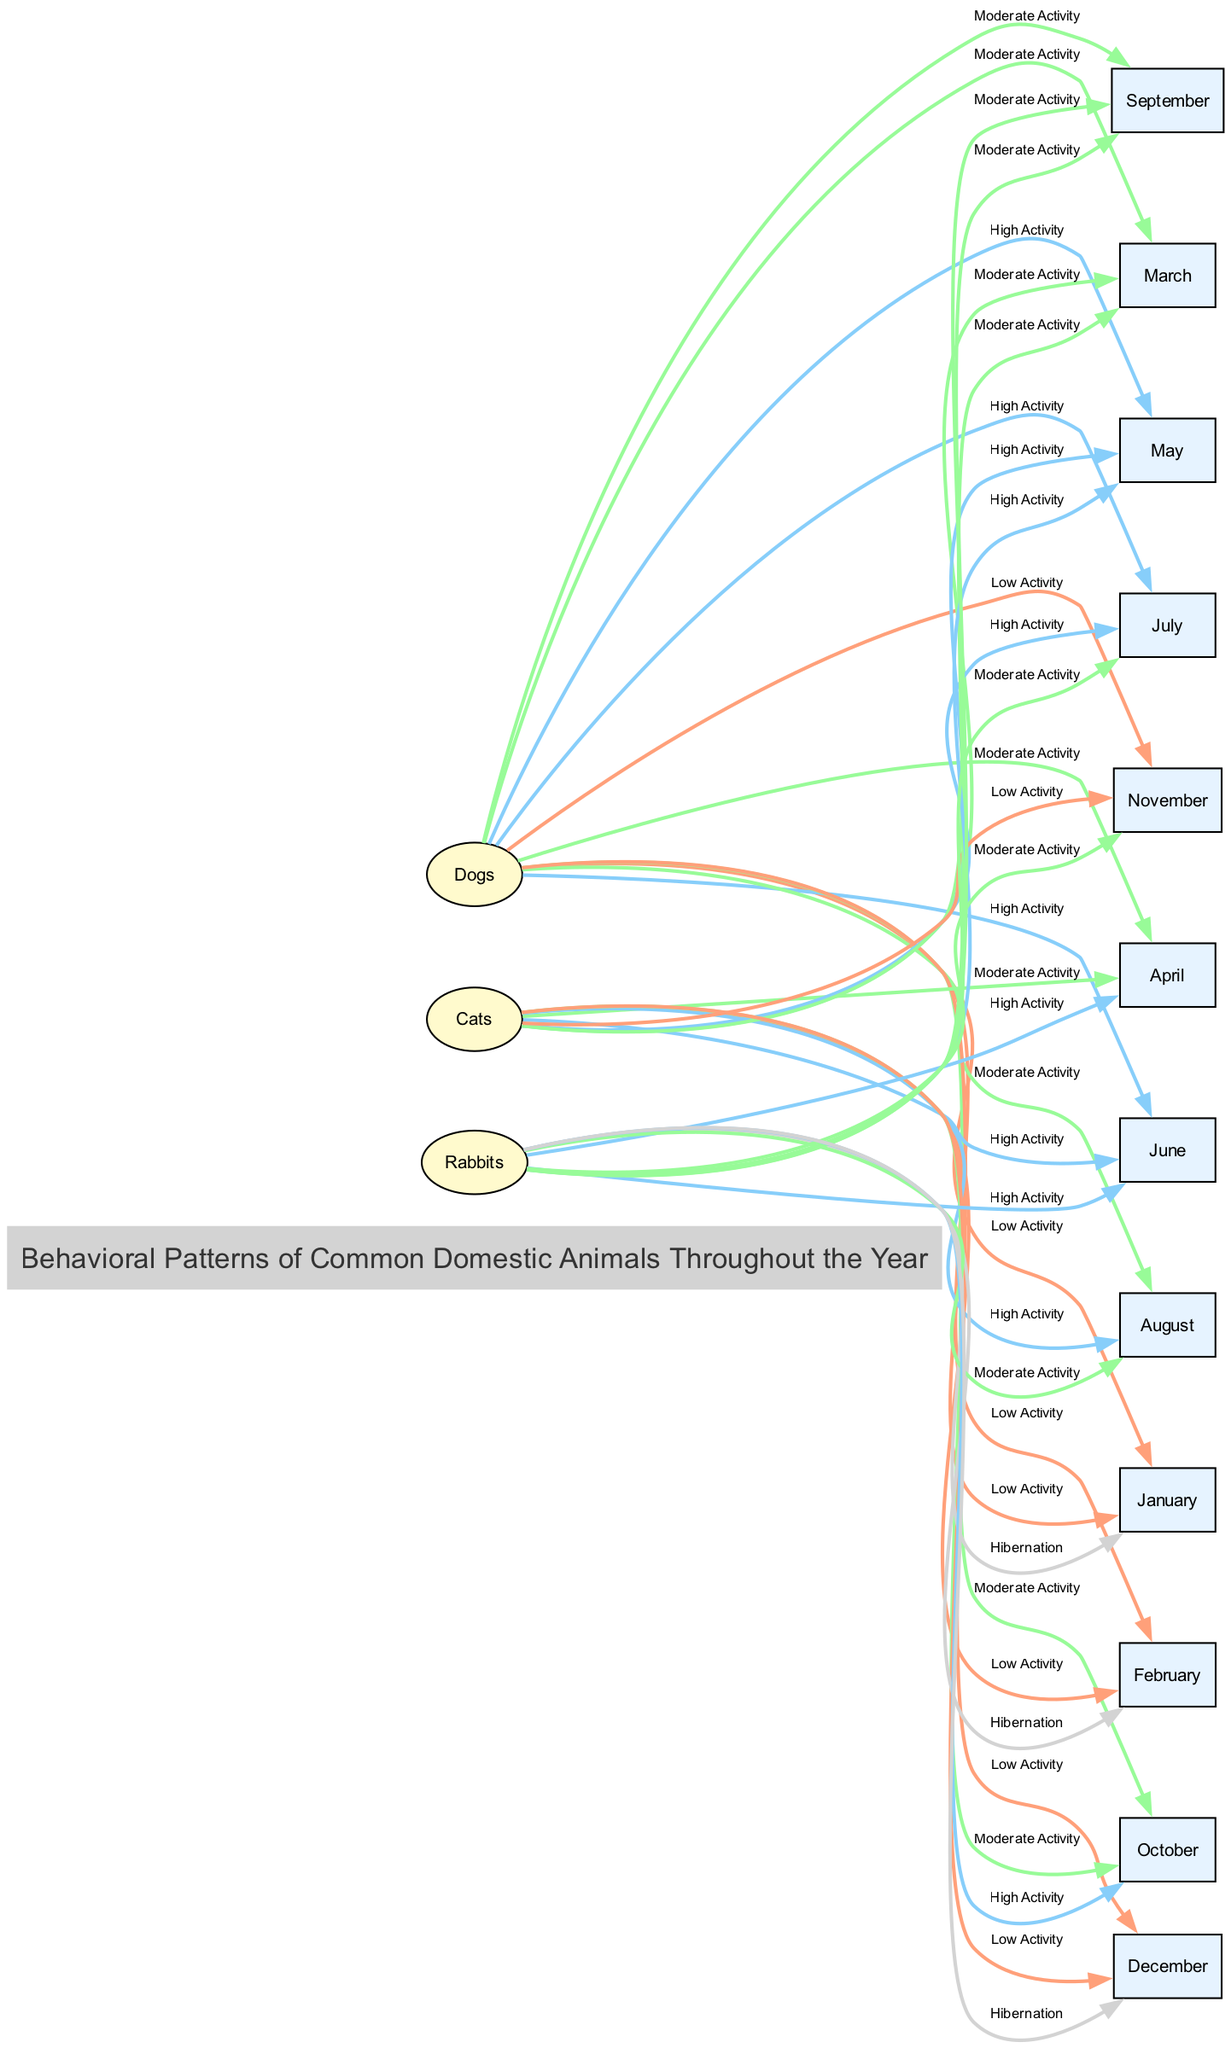What is the activity pattern of dogs in May? According to the diagram, the activity pattern for dogs in May is classified as "High Activity." This is determined by checking the "Dogs" node and following the edge leading to the month of May, which indicates the specified pattern.
Answer: High Activity In which month do rabbits hibernate? The diagram shows that rabbits have the pattern of "Hibernation" in January and December. By examining the nodes for rabbits and the connecting edges to the months, both months show this specific behavior.
Answer: January, December How many behavioral patterns correspond to "Moderate Activity" for cats? By analyzing the edges from the "Cats" node, there are four instances of "Moderate Activity," which appear in March, April, September, and October. This requires counting each occurrence linked with cats' months demonstrating this behavior.
Answer: Four Which animal shows the highest activity in August? To answer this, look at the patterns for each animal in August. Both dogs and cats show "Moderate Activity," but rabbits show "Moderate Activity" in the same month. Comparing the patterns, cats have a "High Activity" classification, which indicates they have the highest level of activity in that month.
Answer: Cats What is the final month of hibernation for rabbits? To find the final month of hibernation for rabbits, examine the last edge connected from the "Rabbits" node. Additionally, looking at the months listed, December is found as the month that indicates "Hibernation," showing it is the last month in the year they hibernate.
Answer: December How many total months show "High Activity" for dogs? By inspecting the edges from the "Dogs" node, we see there are three months (May, June, July) that indicate "High Activity." Therefore, the total number is achieved by counting these months.
Answer: Three 